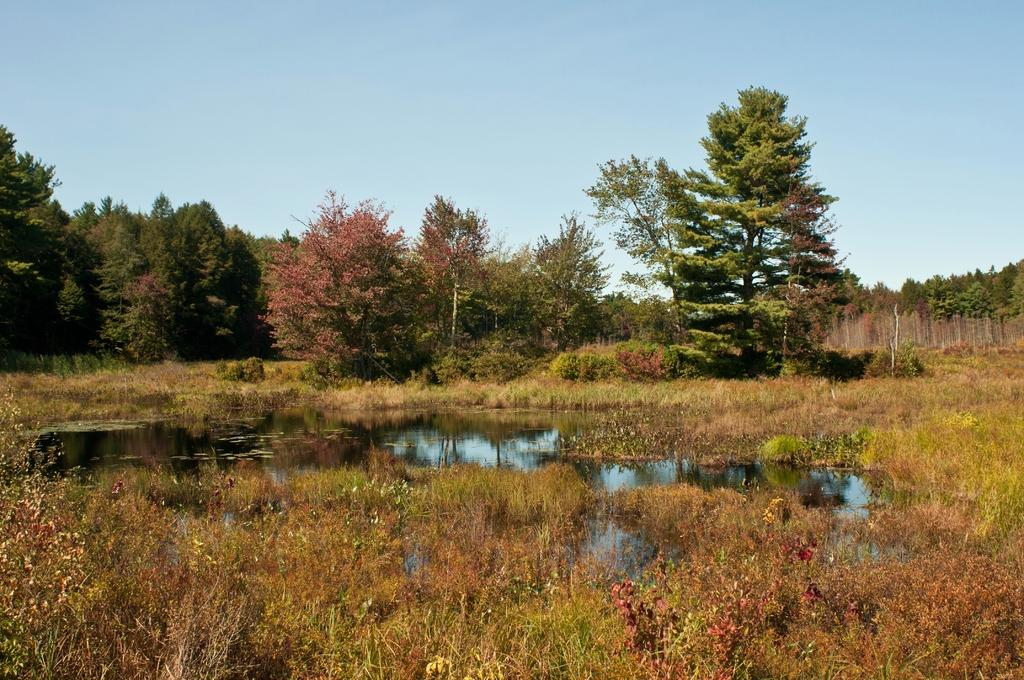Where was the image taken? The image was clicked outside. What type of terrain is visible at the bottom of the image? There is grass at the bottom of the image. What can be seen in the middle of the image? There is water and trees in the middle of the image. What is visible at the top of the image? The sky is visible at the top of the image. How many legs can be seen supporting the egg in the image? There is no egg present in the image, and therefore no legs supporting it. 